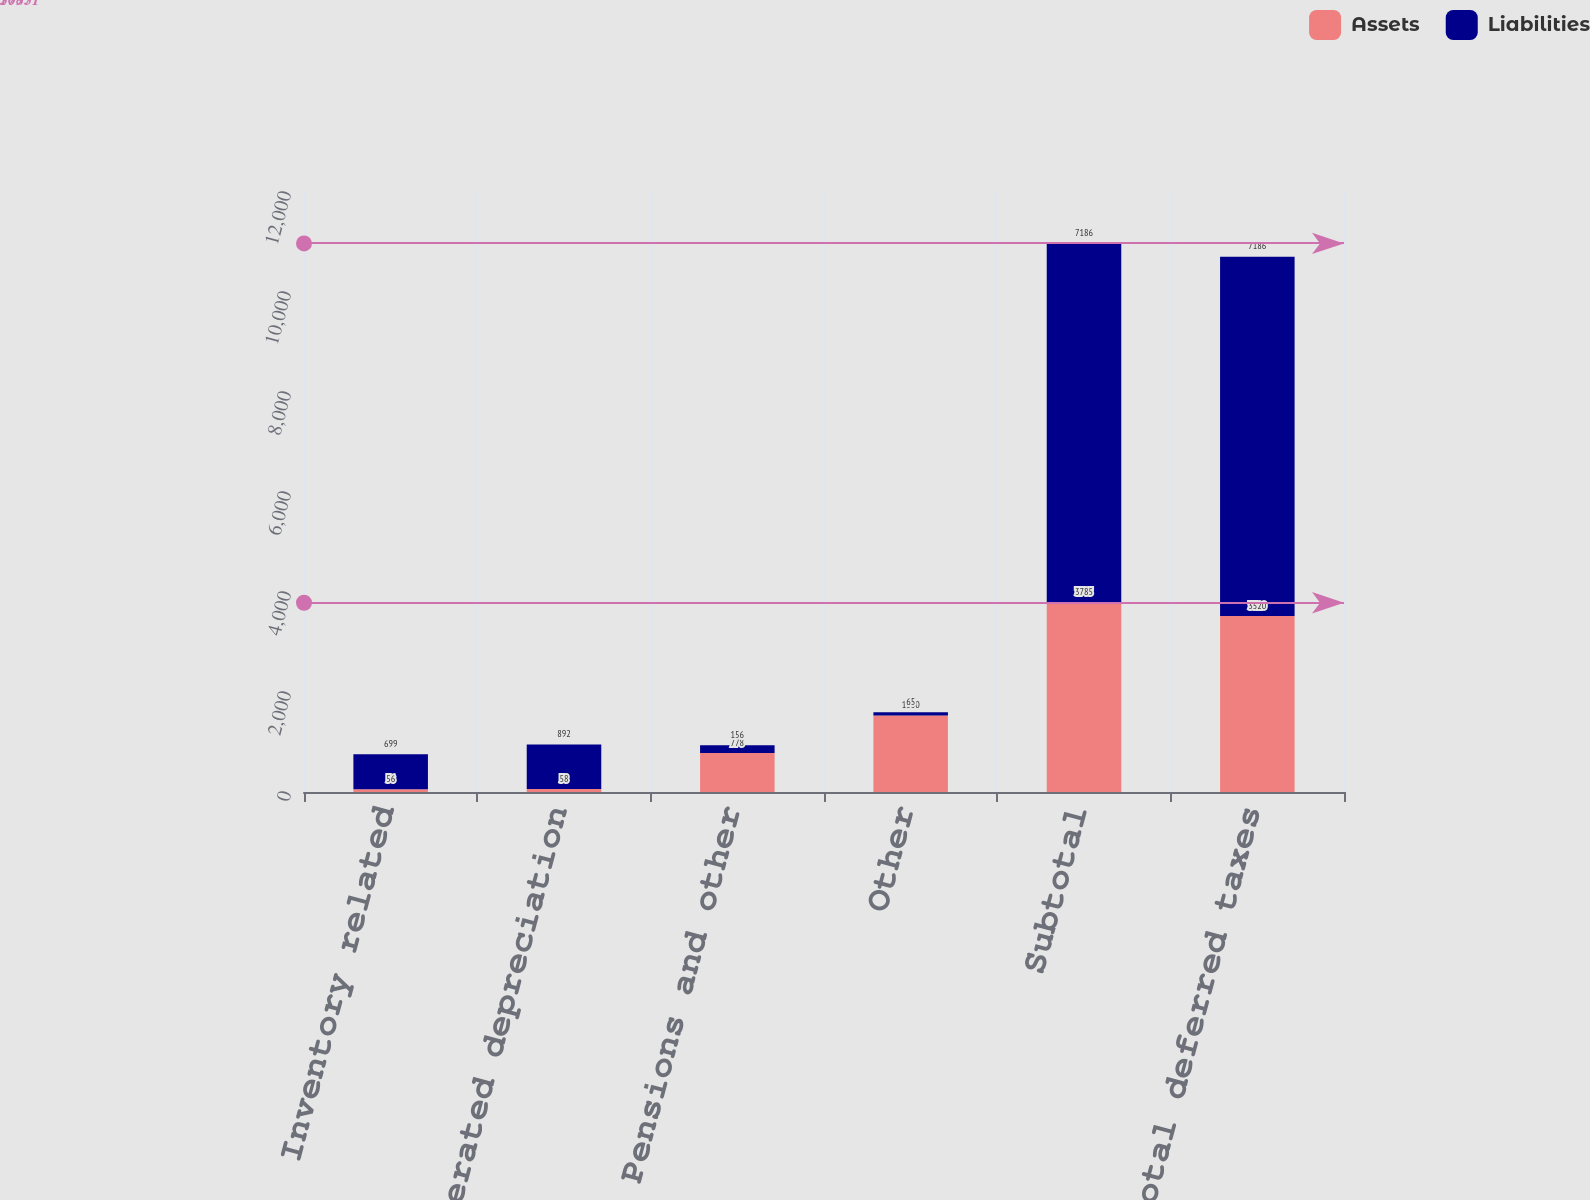Convert chart to OTSL. <chart><loc_0><loc_0><loc_500><loc_500><stacked_bar_chart><ecel><fcel>Inventory related<fcel>Accelerated depreciation<fcel>Pensions and other<fcel>Other<fcel>Subtotal<fcel>Total deferred taxes<nl><fcel>Assets<fcel>56<fcel>58<fcel>778<fcel>1530<fcel>3785<fcel>3520<nl><fcel>Liabilities<fcel>699<fcel>892<fcel>156<fcel>65<fcel>7186<fcel>7186<nl></chart> 